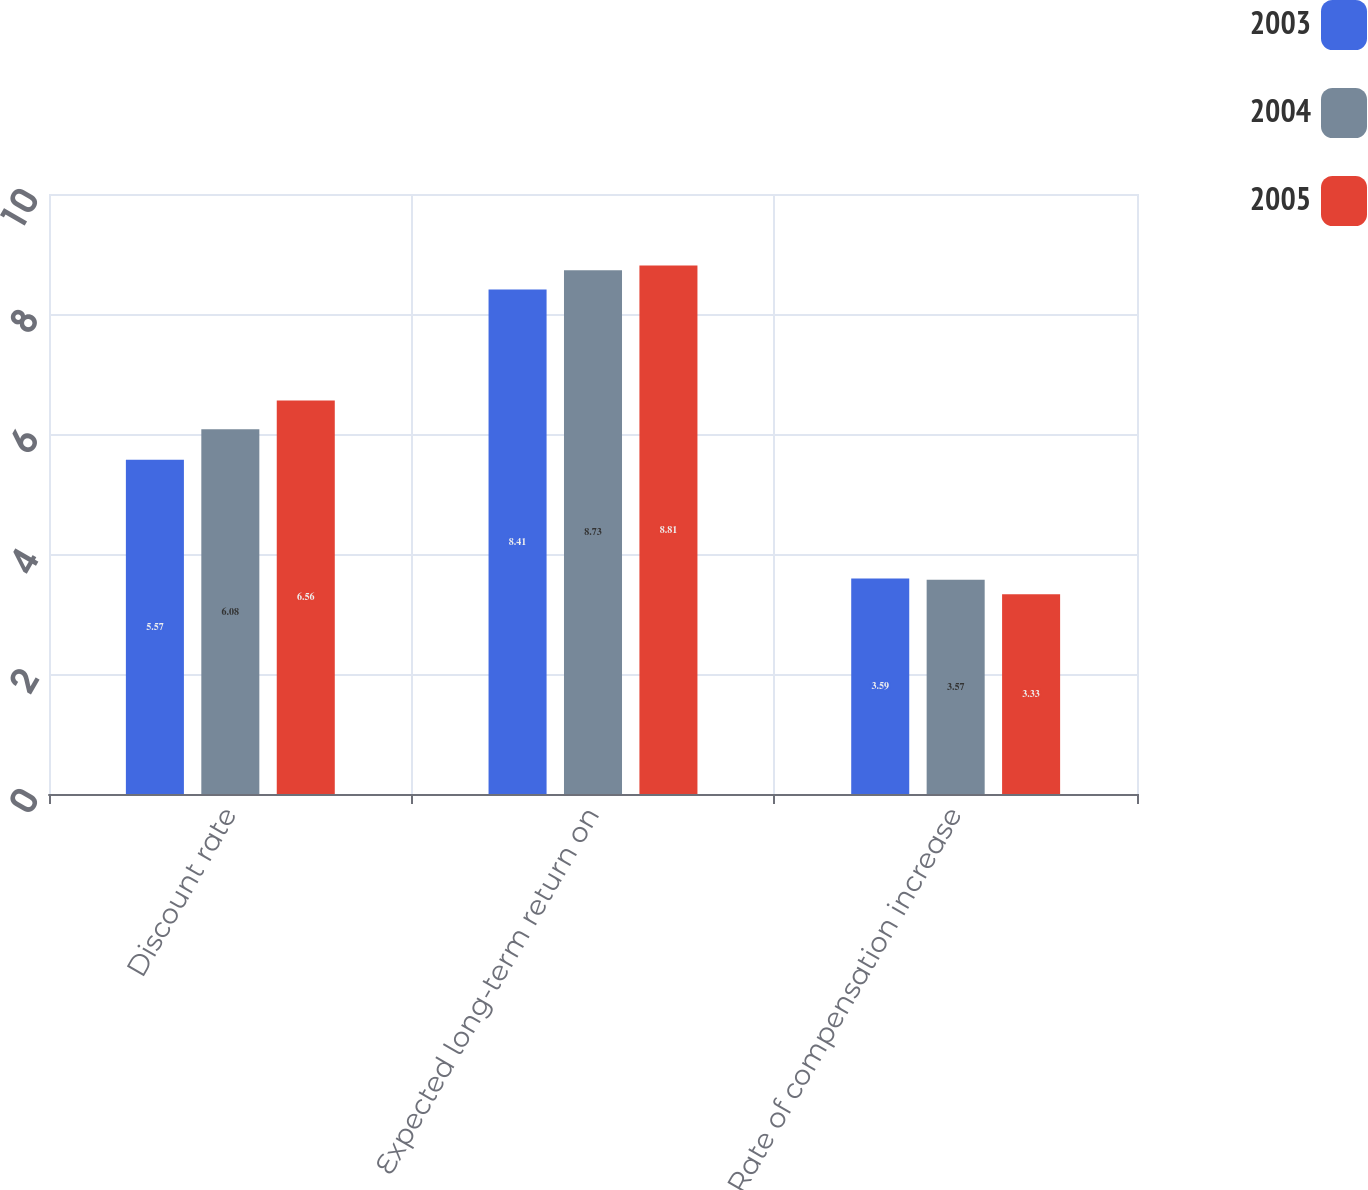Convert chart to OTSL. <chart><loc_0><loc_0><loc_500><loc_500><stacked_bar_chart><ecel><fcel>Discount rate<fcel>Expected long-term return on<fcel>Rate of compensation increase<nl><fcel>2003<fcel>5.57<fcel>8.41<fcel>3.59<nl><fcel>2004<fcel>6.08<fcel>8.73<fcel>3.57<nl><fcel>2005<fcel>6.56<fcel>8.81<fcel>3.33<nl></chart> 